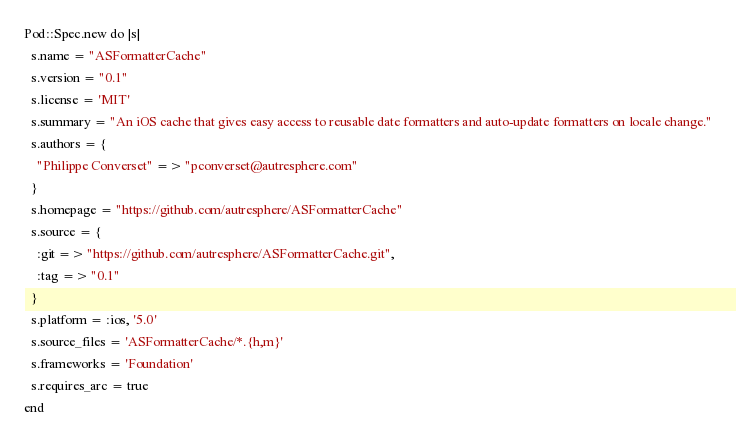<code> <loc_0><loc_0><loc_500><loc_500><_Ruby_>Pod::Spec.new do |s|
  s.name = "ASFormatterCache"
  s.version = "0.1"
  s.license = 'MIT'
  s.summary = "An iOS cache that gives easy access to reusable date formatters and auto-update formatters on locale change."
  s.authors = {
    "Philippe Converset" => "pconverset@autresphere.com"
  }
  s.homepage = "https://github.com/autresphere/ASFormatterCache"
  s.source = {
    :git => "https://github.com/autresphere/ASFormatterCache.git",
    :tag => "0.1"
  }
  s.platform = :ios, '5.0'
  s.source_files = 'ASFormatterCache/*.{h,m}'
  s.frameworks = 'Foundation'
  s.requires_arc = true
end</code> 